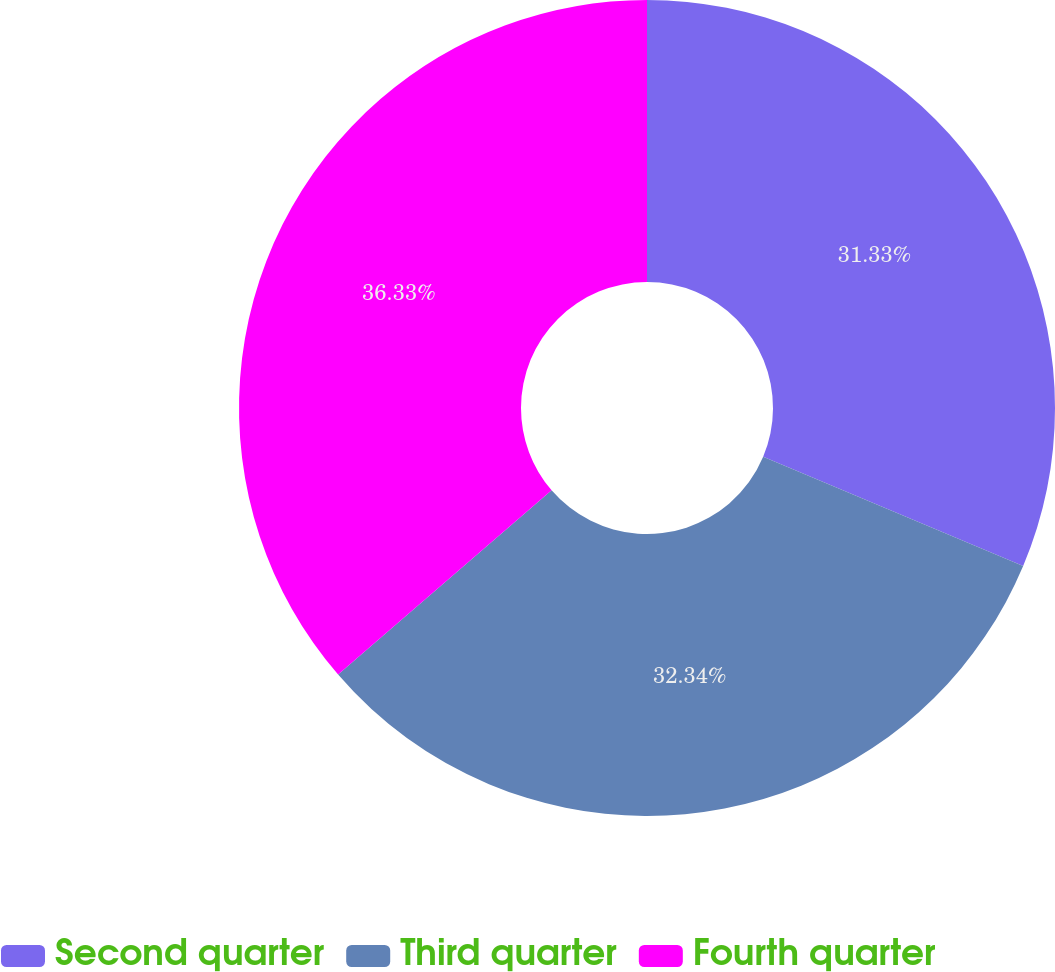Convert chart. <chart><loc_0><loc_0><loc_500><loc_500><pie_chart><fcel>Second quarter<fcel>Third quarter<fcel>Fourth quarter<nl><fcel>31.33%<fcel>32.34%<fcel>36.33%<nl></chart> 